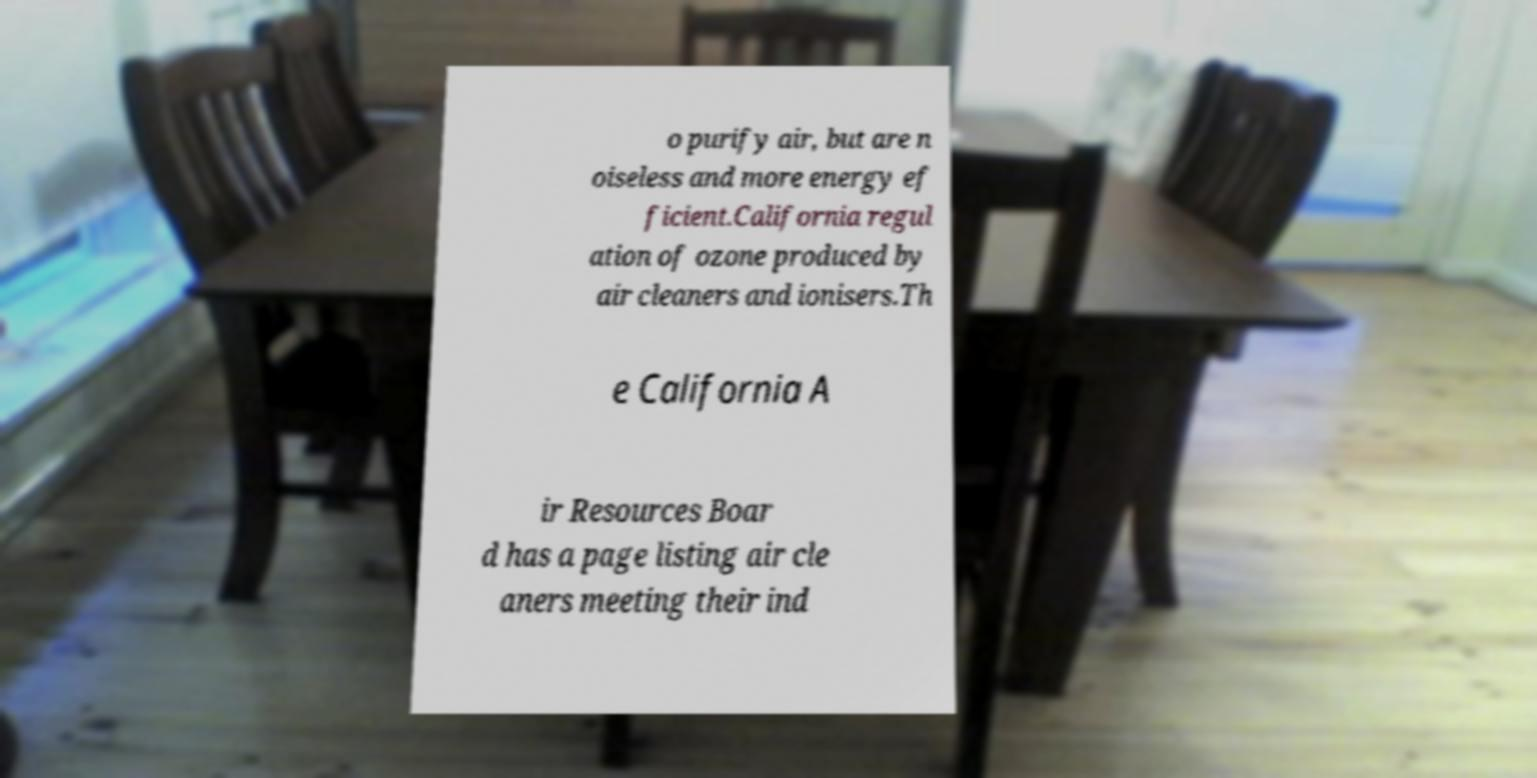Can you read and provide the text displayed in the image?This photo seems to have some interesting text. Can you extract and type it out for me? o purify air, but are n oiseless and more energy ef ficient.California regul ation of ozone produced by air cleaners and ionisers.Th e California A ir Resources Boar d has a page listing air cle aners meeting their ind 